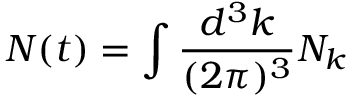Convert formula to latex. <formula><loc_0><loc_0><loc_500><loc_500>N ( t ) = \int \frac { d ^ { 3 } k } { ( 2 \pi ) ^ { 3 } } N _ { k }</formula> 